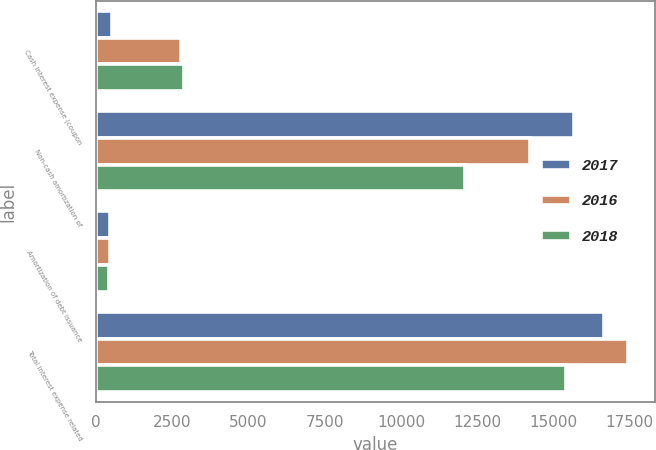Convert chart. <chart><loc_0><loc_0><loc_500><loc_500><stacked_bar_chart><ecel><fcel>Cash interest expense (coupon<fcel>Non-cash amortization of<fcel>Amortization of debt issuance<fcel>Total interest expense related<nl><fcel>2017<fcel>539<fcel>15662<fcel>466<fcel>16667<nl><fcel>2016<fcel>2784<fcel>14221<fcel>453<fcel>17458<nl><fcel>2018<fcel>2875<fcel>12085<fcel>443<fcel>15403<nl></chart> 